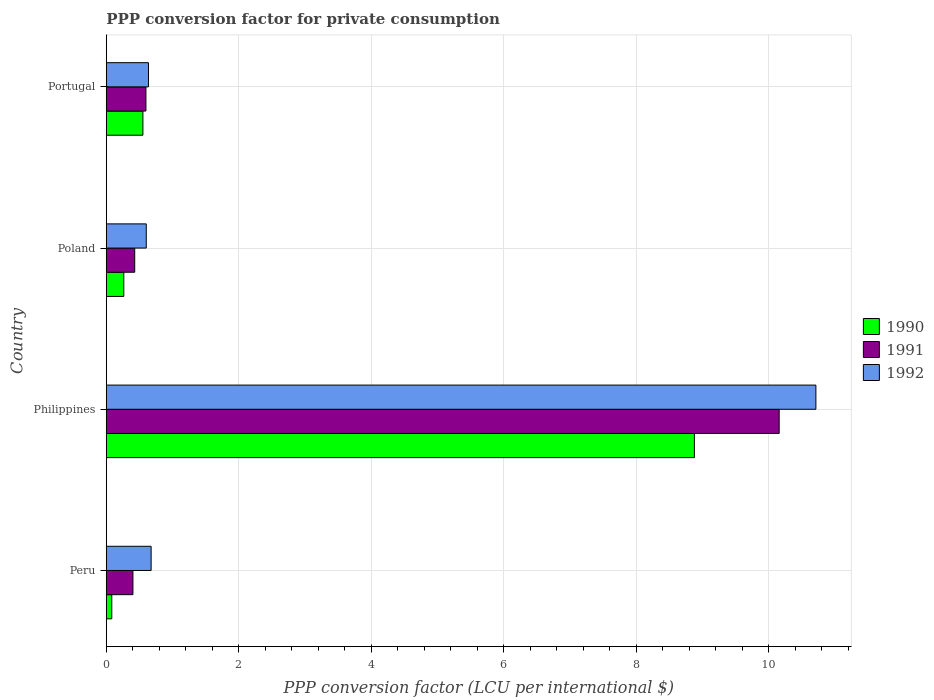How many groups of bars are there?
Provide a succinct answer. 4. Are the number of bars per tick equal to the number of legend labels?
Offer a terse response. Yes. What is the label of the 1st group of bars from the top?
Keep it short and to the point. Portugal. In how many cases, is the number of bars for a given country not equal to the number of legend labels?
Provide a succinct answer. 0. What is the PPP conversion factor for private consumption in 1991 in Poland?
Provide a short and direct response. 0.43. Across all countries, what is the maximum PPP conversion factor for private consumption in 1992?
Your answer should be very brief. 10.71. Across all countries, what is the minimum PPP conversion factor for private consumption in 1990?
Provide a succinct answer. 0.08. What is the total PPP conversion factor for private consumption in 1991 in the graph?
Your response must be concise. 11.58. What is the difference between the PPP conversion factor for private consumption in 1991 in Peru and that in Philippines?
Ensure brevity in your answer.  -9.75. What is the difference between the PPP conversion factor for private consumption in 1991 in Philippines and the PPP conversion factor for private consumption in 1992 in Portugal?
Your answer should be very brief. 9.52. What is the average PPP conversion factor for private consumption in 1992 per country?
Ensure brevity in your answer.  3.16. What is the difference between the PPP conversion factor for private consumption in 1991 and PPP conversion factor for private consumption in 1990 in Philippines?
Make the answer very short. 1.28. What is the ratio of the PPP conversion factor for private consumption in 1991 in Peru to that in Philippines?
Make the answer very short. 0.04. Is the difference between the PPP conversion factor for private consumption in 1991 in Philippines and Portugal greater than the difference between the PPP conversion factor for private consumption in 1990 in Philippines and Portugal?
Make the answer very short. Yes. What is the difference between the highest and the second highest PPP conversion factor for private consumption in 1990?
Provide a succinct answer. 8.32. What is the difference between the highest and the lowest PPP conversion factor for private consumption in 1991?
Offer a terse response. 9.75. In how many countries, is the PPP conversion factor for private consumption in 1992 greater than the average PPP conversion factor for private consumption in 1992 taken over all countries?
Make the answer very short. 1. Is the sum of the PPP conversion factor for private consumption in 1992 in Philippines and Poland greater than the maximum PPP conversion factor for private consumption in 1991 across all countries?
Give a very brief answer. Yes. What does the 2nd bar from the top in Philippines represents?
Provide a short and direct response. 1991. How many bars are there?
Provide a short and direct response. 12. Are all the bars in the graph horizontal?
Provide a succinct answer. Yes. Are the values on the major ticks of X-axis written in scientific E-notation?
Ensure brevity in your answer.  No. How many legend labels are there?
Ensure brevity in your answer.  3. What is the title of the graph?
Your answer should be very brief. PPP conversion factor for private consumption. Does "1995" appear as one of the legend labels in the graph?
Ensure brevity in your answer.  No. What is the label or title of the X-axis?
Your response must be concise. PPP conversion factor (LCU per international $). What is the label or title of the Y-axis?
Your response must be concise. Country. What is the PPP conversion factor (LCU per international $) in 1990 in Peru?
Your answer should be compact. 0.08. What is the PPP conversion factor (LCU per international $) in 1991 in Peru?
Your response must be concise. 0.4. What is the PPP conversion factor (LCU per international $) of 1992 in Peru?
Make the answer very short. 0.68. What is the PPP conversion factor (LCU per international $) of 1990 in Philippines?
Ensure brevity in your answer.  8.88. What is the PPP conversion factor (LCU per international $) of 1991 in Philippines?
Make the answer very short. 10.15. What is the PPP conversion factor (LCU per international $) in 1992 in Philippines?
Your answer should be very brief. 10.71. What is the PPP conversion factor (LCU per international $) in 1990 in Poland?
Your answer should be very brief. 0.26. What is the PPP conversion factor (LCU per international $) of 1991 in Poland?
Your answer should be very brief. 0.43. What is the PPP conversion factor (LCU per international $) of 1992 in Poland?
Offer a terse response. 0.6. What is the PPP conversion factor (LCU per international $) in 1990 in Portugal?
Keep it short and to the point. 0.55. What is the PPP conversion factor (LCU per international $) of 1991 in Portugal?
Keep it short and to the point. 0.6. What is the PPP conversion factor (LCU per international $) in 1992 in Portugal?
Give a very brief answer. 0.64. Across all countries, what is the maximum PPP conversion factor (LCU per international $) of 1990?
Your response must be concise. 8.88. Across all countries, what is the maximum PPP conversion factor (LCU per international $) of 1991?
Provide a short and direct response. 10.15. Across all countries, what is the maximum PPP conversion factor (LCU per international $) of 1992?
Give a very brief answer. 10.71. Across all countries, what is the minimum PPP conversion factor (LCU per international $) of 1990?
Your answer should be very brief. 0.08. Across all countries, what is the minimum PPP conversion factor (LCU per international $) of 1991?
Your answer should be compact. 0.4. Across all countries, what is the minimum PPP conversion factor (LCU per international $) of 1992?
Provide a succinct answer. 0.6. What is the total PPP conversion factor (LCU per international $) of 1990 in the graph?
Keep it short and to the point. 9.77. What is the total PPP conversion factor (LCU per international $) of 1991 in the graph?
Give a very brief answer. 11.58. What is the total PPP conversion factor (LCU per international $) of 1992 in the graph?
Your answer should be very brief. 12.62. What is the difference between the PPP conversion factor (LCU per international $) of 1990 in Peru and that in Philippines?
Provide a short and direct response. -8.79. What is the difference between the PPP conversion factor (LCU per international $) of 1991 in Peru and that in Philippines?
Your answer should be very brief. -9.75. What is the difference between the PPP conversion factor (LCU per international $) of 1992 in Peru and that in Philippines?
Make the answer very short. -10.03. What is the difference between the PPP conversion factor (LCU per international $) in 1990 in Peru and that in Poland?
Provide a short and direct response. -0.18. What is the difference between the PPP conversion factor (LCU per international $) of 1991 in Peru and that in Poland?
Keep it short and to the point. -0.03. What is the difference between the PPP conversion factor (LCU per international $) of 1992 in Peru and that in Poland?
Give a very brief answer. 0.07. What is the difference between the PPP conversion factor (LCU per international $) in 1990 in Peru and that in Portugal?
Your answer should be compact. -0.47. What is the difference between the PPP conversion factor (LCU per international $) in 1991 in Peru and that in Portugal?
Your answer should be compact. -0.2. What is the difference between the PPP conversion factor (LCU per international $) in 1992 in Peru and that in Portugal?
Offer a terse response. 0.04. What is the difference between the PPP conversion factor (LCU per international $) in 1990 in Philippines and that in Poland?
Provide a short and direct response. 8.61. What is the difference between the PPP conversion factor (LCU per international $) of 1991 in Philippines and that in Poland?
Ensure brevity in your answer.  9.73. What is the difference between the PPP conversion factor (LCU per international $) of 1992 in Philippines and that in Poland?
Offer a terse response. 10.11. What is the difference between the PPP conversion factor (LCU per international $) in 1990 in Philippines and that in Portugal?
Make the answer very short. 8.32. What is the difference between the PPP conversion factor (LCU per international $) in 1991 in Philippines and that in Portugal?
Provide a succinct answer. 9.56. What is the difference between the PPP conversion factor (LCU per international $) of 1992 in Philippines and that in Portugal?
Ensure brevity in your answer.  10.07. What is the difference between the PPP conversion factor (LCU per international $) in 1990 in Poland and that in Portugal?
Offer a terse response. -0.29. What is the difference between the PPP conversion factor (LCU per international $) in 1991 in Poland and that in Portugal?
Keep it short and to the point. -0.17. What is the difference between the PPP conversion factor (LCU per international $) of 1992 in Poland and that in Portugal?
Provide a succinct answer. -0.03. What is the difference between the PPP conversion factor (LCU per international $) of 1990 in Peru and the PPP conversion factor (LCU per international $) of 1991 in Philippines?
Provide a short and direct response. -10.07. What is the difference between the PPP conversion factor (LCU per international $) of 1990 in Peru and the PPP conversion factor (LCU per international $) of 1992 in Philippines?
Your response must be concise. -10.63. What is the difference between the PPP conversion factor (LCU per international $) of 1991 in Peru and the PPP conversion factor (LCU per international $) of 1992 in Philippines?
Your answer should be very brief. -10.31. What is the difference between the PPP conversion factor (LCU per international $) of 1990 in Peru and the PPP conversion factor (LCU per international $) of 1991 in Poland?
Offer a very short reply. -0.35. What is the difference between the PPP conversion factor (LCU per international $) of 1990 in Peru and the PPP conversion factor (LCU per international $) of 1992 in Poland?
Offer a very short reply. -0.52. What is the difference between the PPP conversion factor (LCU per international $) in 1991 in Peru and the PPP conversion factor (LCU per international $) in 1992 in Poland?
Keep it short and to the point. -0.2. What is the difference between the PPP conversion factor (LCU per international $) of 1990 in Peru and the PPP conversion factor (LCU per international $) of 1991 in Portugal?
Your answer should be very brief. -0.52. What is the difference between the PPP conversion factor (LCU per international $) of 1990 in Peru and the PPP conversion factor (LCU per international $) of 1992 in Portugal?
Your answer should be compact. -0.55. What is the difference between the PPP conversion factor (LCU per international $) of 1991 in Peru and the PPP conversion factor (LCU per international $) of 1992 in Portugal?
Make the answer very short. -0.23. What is the difference between the PPP conversion factor (LCU per international $) in 1990 in Philippines and the PPP conversion factor (LCU per international $) in 1991 in Poland?
Ensure brevity in your answer.  8.45. What is the difference between the PPP conversion factor (LCU per international $) in 1990 in Philippines and the PPP conversion factor (LCU per international $) in 1992 in Poland?
Make the answer very short. 8.27. What is the difference between the PPP conversion factor (LCU per international $) in 1991 in Philippines and the PPP conversion factor (LCU per international $) in 1992 in Poland?
Provide a short and direct response. 9.55. What is the difference between the PPP conversion factor (LCU per international $) of 1990 in Philippines and the PPP conversion factor (LCU per international $) of 1991 in Portugal?
Provide a succinct answer. 8.28. What is the difference between the PPP conversion factor (LCU per international $) in 1990 in Philippines and the PPP conversion factor (LCU per international $) in 1992 in Portugal?
Your response must be concise. 8.24. What is the difference between the PPP conversion factor (LCU per international $) in 1991 in Philippines and the PPP conversion factor (LCU per international $) in 1992 in Portugal?
Provide a short and direct response. 9.52. What is the difference between the PPP conversion factor (LCU per international $) in 1990 in Poland and the PPP conversion factor (LCU per international $) in 1991 in Portugal?
Your answer should be very brief. -0.33. What is the difference between the PPP conversion factor (LCU per international $) in 1990 in Poland and the PPP conversion factor (LCU per international $) in 1992 in Portugal?
Offer a terse response. -0.37. What is the difference between the PPP conversion factor (LCU per international $) of 1991 in Poland and the PPP conversion factor (LCU per international $) of 1992 in Portugal?
Give a very brief answer. -0.21. What is the average PPP conversion factor (LCU per international $) of 1990 per country?
Ensure brevity in your answer.  2.44. What is the average PPP conversion factor (LCU per international $) in 1991 per country?
Provide a succinct answer. 2.9. What is the average PPP conversion factor (LCU per international $) in 1992 per country?
Provide a short and direct response. 3.16. What is the difference between the PPP conversion factor (LCU per international $) in 1990 and PPP conversion factor (LCU per international $) in 1991 in Peru?
Give a very brief answer. -0.32. What is the difference between the PPP conversion factor (LCU per international $) of 1990 and PPP conversion factor (LCU per international $) of 1992 in Peru?
Offer a very short reply. -0.59. What is the difference between the PPP conversion factor (LCU per international $) of 1991 and PPP conversion factor (LCU per international $) of 1992 in Peru?
Give a very brief answer. -0.27. What is the difference between the PPP conversion factor (LCU per international $) in 1990 and PPP conversion factor (LCU per international $) in 1991 in Philippines?
Keep it short and to the point. -1.28. What is the difference between the PPP conversion factor (LCU per international $) in 1990 and PPP conversion factor (LCU per international $) in 1992 in Philippines?
Provide a succinct answer. -1.83. What is the difference between the PPP conversion factor (LCU per international $) of 1991 and PPP conversion factor (LCU per international $) of 1992 in Philippines?
Your response must be concise. -0.55. What is the difference between the PPP conversion factor (LCU per international $) in 1990 and PPP conversion factor (LCU per international $) in 1991 in Poland?
Offer a terse response. -0.16. What is the difference between the PPP conversion factor (LCU per international $) of 1990 and PPP conversion factor (LCU per international $) of 1992 in Poland?
Offer a very short reply. -0.34. What is the difference between the PPP conversion factor (LCU per international $) in 1991 and PPP conversion factor (LCU per international $) in 1992 in Poland?
Offer a terse response. -0.17. What is the difference between the PPP conversion factor (LCU per international $) of 1990 and PPP conversion factor (LCU per international $) of 1991 in Portugal?
Offer a terse response. -0.05. What is the difference between the PPP conversion factor (LCU per international $) in 1990 and PPP conversion factor (LCU per international $) in 1992 in Portugal?
Make the answer very short. -0.08. What is the difference between the PPP conversion factor (LCU per international $) of 1991 and PPP conversion factor (LCU per international $) of 1992 in Portugal?
Give a very brief answer. -0.04. What is the ratio of the PPP conversion factor (LCU per international $) of 1990 in Peru to that in Philippines?
Offer a very short reply. 0.01. What is the ratio of the PPP conversion factor (LCU per international $) of 1991 in Peru to that in Philippines?
Offer a very short reply. 0.04. What is the ratio of the PPP conversion factor (LCU per international $) of 1992 in Peru to that in Philippines?
Keep it short and to the point. 0.06. What is the ratio of the PPP conversion factor (LCU per international $) of 1990 in Peru to that in Poland?
Keep it short and to the point. 0.31. What is the ratio of the PPP conversion factor (LCU per international $) of 1991 in Peru to that in Poland?
Provide a succinct answer. 0.94. What is the ratio of the PPP conversion factor (LCU per international $) of 1992 in Peru to that in Poland?
Provide a short and direct response. 1.12. What is the ratio of the PPP conversion factor (LCU per international $) in 1990 in Peru to that in Portugal?
Offer a very short reply. 0.15. What is the ratio of the PPP conversion factor (LCU per international $) of 1991 in Peru to that in Portugal?
Provide a succinct answer. 0.67. What is the ratio of the PPP conversion factor (LCU per international $) in 1992 in Peru to that in Portugal?
Keep it short and to the point. 1.06. What is the ratio of the PPP conversion factor (LCU per international $) of 1990 in Philippines to that in Poland?
Make the answer very short. 33.67. What is the ratio of the PPP conversion factor (LCU per international $) of 1991 in Philippines to that in Poland?
Keep it short and to the point. 23.71. What is the ratio of the PPP conversion factor (LCU per international $) of 1992 in Philippines to that in Poland?
Offer a terse response. 17.77. What is the ratio of the PPP conversion factor (LCU per international $) of 1990 in Philippines to that in Portugal?
Keep it short and to the point. 16.08. What is the ratio of the PPP conversion factor (LCU per international $) of 1991 in Philippines to that in Portugal?
Offer a terse response. 16.99. What is the ratio of the PPP conversion factor (LCU per international $) of 1992 in Philippines to that in Portugal?
Keep it short and to the point. 16.84. What is the ratio of the PPP conversion factor (LCU per international $) in 1990 in Poland to that in Portugal?
Make the answer very short. 0.48. What is the ratio of the PPP conversion factor (LCU per international $) in 1991 in Poland to that in Portugal?
Give a very brief answer. 0.72. What is the ratio of the PPP conversion factor (LCU per international $) of 1992 in Poland to that in Portugal?
Provide a short and direct response. 0.95. What is the difference between the highest and the second highest PPP conversion factor (LCU per international $) in 1990?
Offer a very short reply. 8.32. What is the difference between the highest and the second highest PPP conversion factor (LCU per international $) of 1991?
Provide a short and direct response. 9.56. What is the difference between the highest and the second highest PPP conversion factor (LCU per international $) of 1992?
Give a very brief answer. 10.03. What is the difference between the highest and the lowest PPP conversion factor (LCU per international $) of 1990?
Provide a short and direct response. 8.79. What is the difference between the highest and the lowest PPP conversion factor (LCU per international $) in 1991?
Make the answer very short. 9.75. What is the difference between the highest and the lowest PPP conversion factor (LCU per international $) in 1992?
Your answer should be very brief. 10.11. 